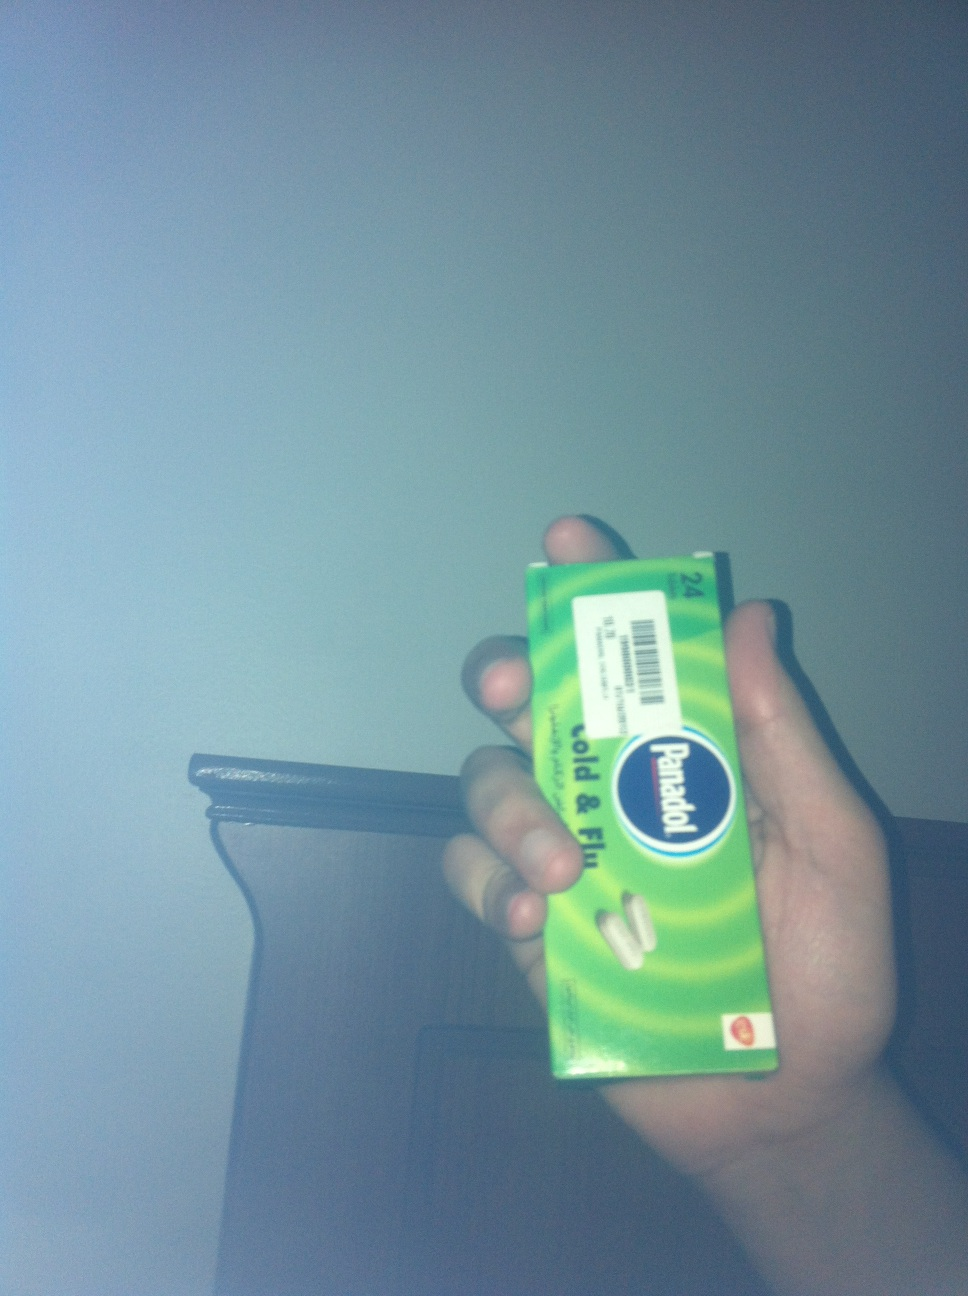What is this? The item in the image is 'Panadol Cold & Flu' medicine. It is typically used to relieve symptoms associated with the common cold and flu, such as headaches, fever, and minor aches. This pack specifically contains caplets as indicated on the packaging. 